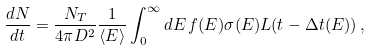Convert formula to latex. <formula><loc_0><loc_0><loc_500><loc_500>\frac { d N } { d t } = \frac { N _ { T } } { 4 \pi D ^ { 2 } } \frac { 1 } { \langle E \rangle } \int _ { 0 } ^ { \infty } d E \, f ( E ) \sigma ( E ) L ( t - \Delta t ( E ) ) \, ,</formula> 